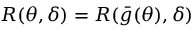Convert formula to latex. <formula><loc_0><loc_0><loc_500><loc_500>R ( \theta , \delta ) = R ( { \bar { g } } ( \theta ) , \delta )</formula> 